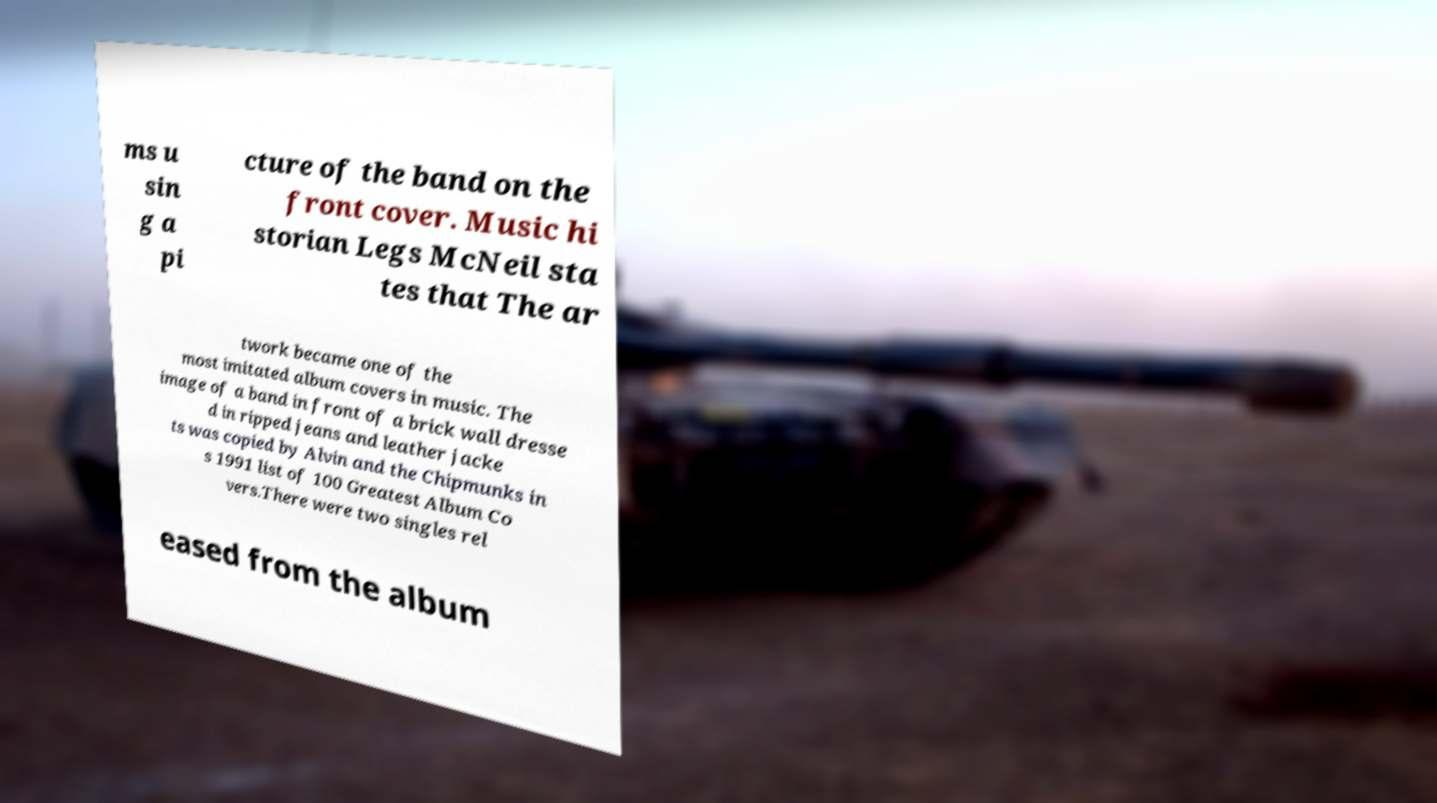Please identify and transcribe the text found in this image. ms u sin g a pi cture of the band on the front cover. Music hi storian Legs McNeil sta tes that The ar twork became one of the most imitated album covers in music. The image of a band in front of a brick wall dresse d in ripped jeans and leather jacke ts was copied by Alvin and the Chipmunks in s 1991 list of 100 Greatest Album Co vers.There were two singles rel eased from the album 